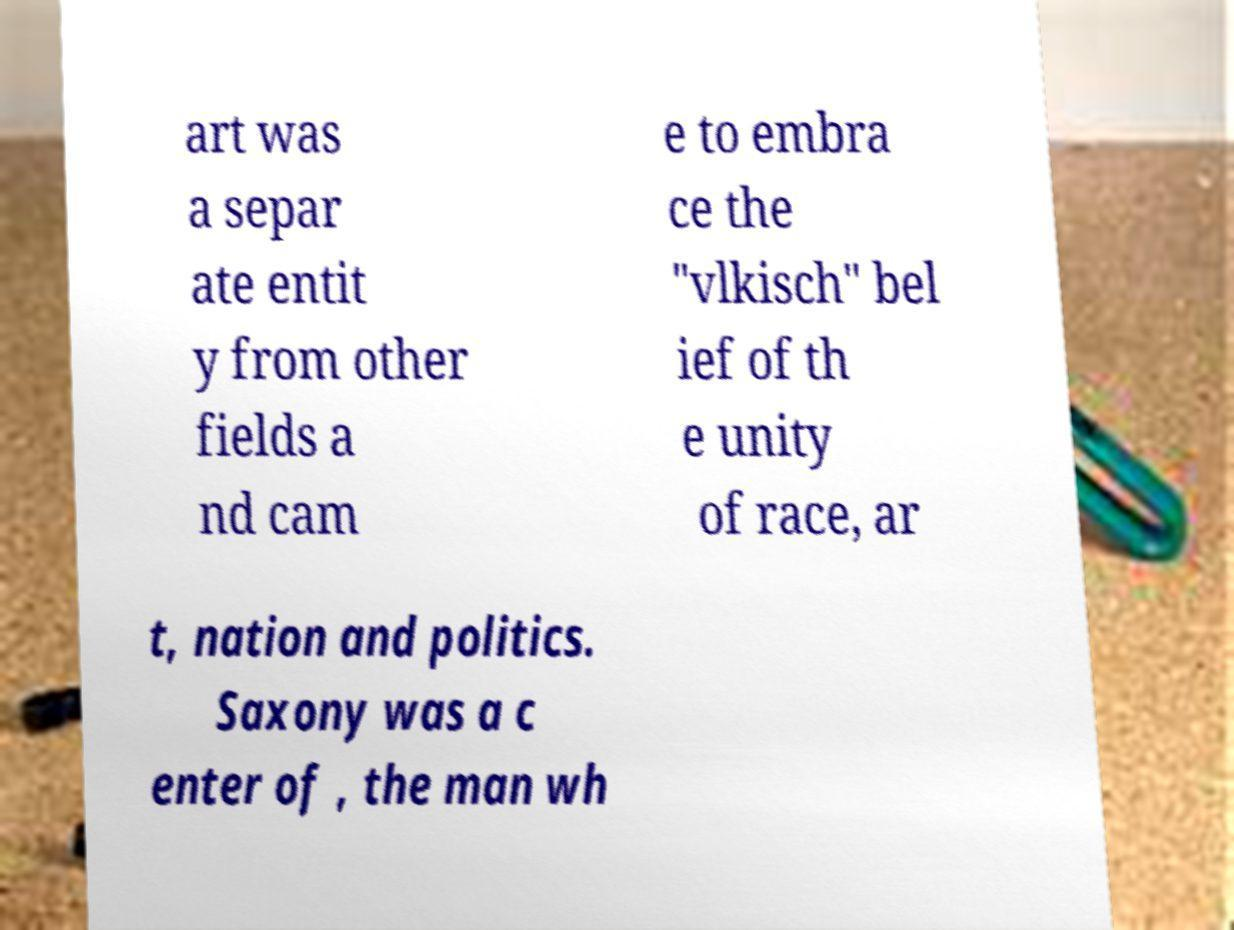What messages or text are displayed in this image? I need them in a readable, typed format. art was a separ ate entit y from other fields a nd cam e to embra ce the "vlkisch" bel ief of th e unity of race, ar t, nation and politics. Saxony was a c enter of , the man wh 